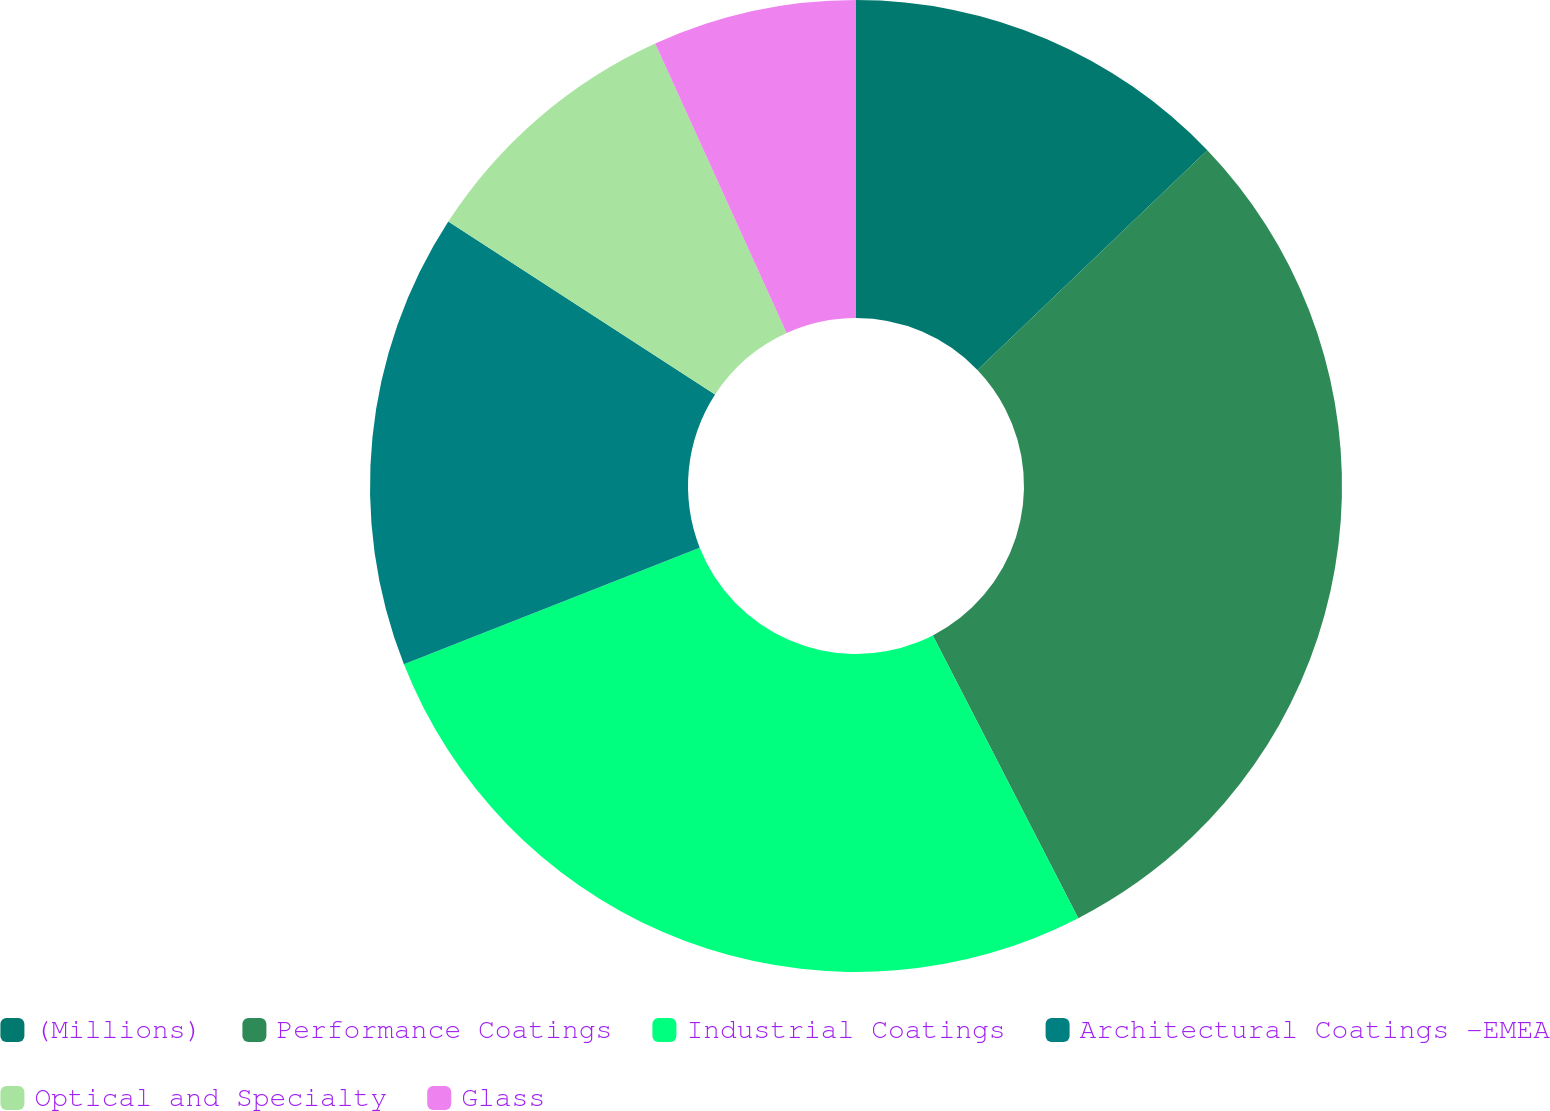Convert chart to OTSL. <chart><loc_0><loc_0><loc_500><loc_500><pie_chart><fcel>(Millions)<fcel>Performance Coatings<fcel>Industrial Coatings<fcel>Architectural Coatings -EMEA<fcel>Optical and Specialty<fcel>Glass<nl><fcel>12.86%<fcel>29.58%<fcel>26.58%<fcel>15.14%<fcel>9.06%<fcel>6.78%<nl></chart> 